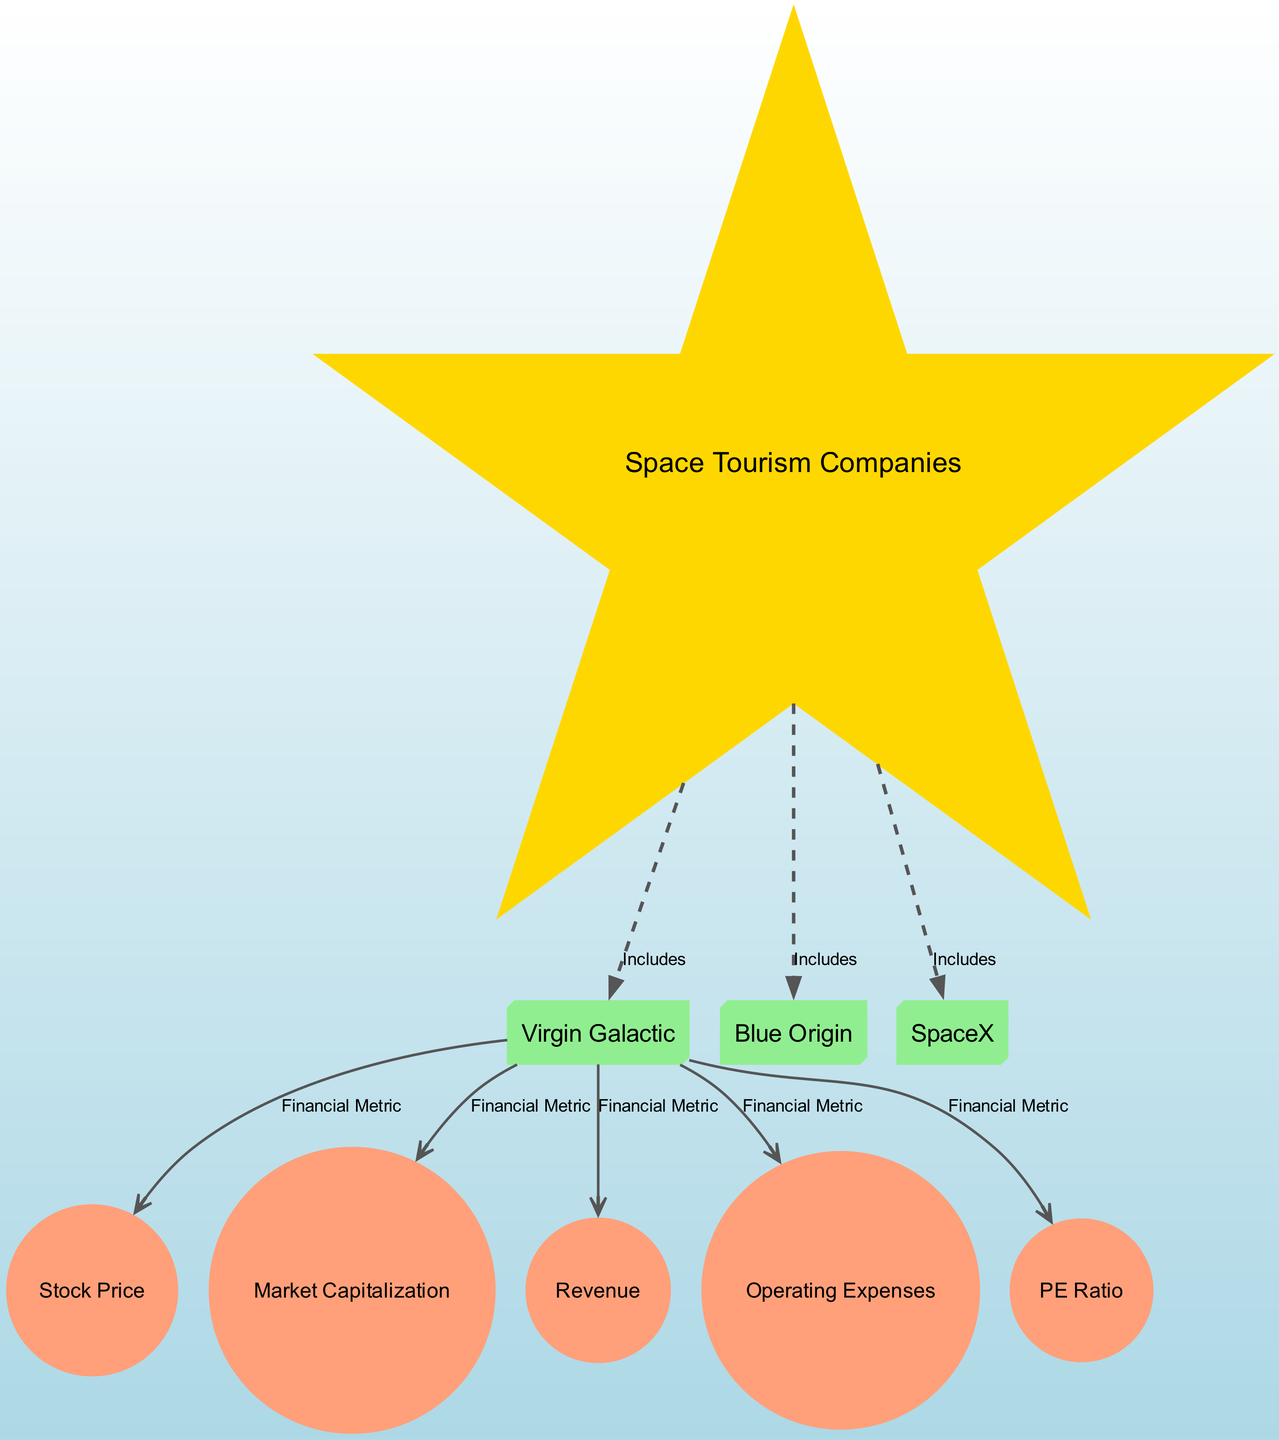What are the space tourism companies included in the diagram? The diagram includes a central node labeled "Space Tourism Companies," which has edges connecting to three nodes: "Virgin Galactic," "Blue Origin," and "SpaceX." This shows that these three companies are included in the space tourism sector.
Answer: Virgin Galactic, Blue Origin, SpaceX How many financial metrics are associated with Virgin Galactic? From the diagram, Virgin Galactic has five edges connecting to different financial metrics: "Stock Price," "Market Capitalization," "Revenue," "Operating Expenses," and "PE Ratio." Therefore, the number of financial metrics associated with Virgin Galactic is five.
Answer: 5 Which company is associated with the highest number of financial metrics? By examining the edges, we see that each of the three space tourism companies (Virgin Galactic, Blue Origin, SpaceX) is connected to the same five financial metrics, indicating they all have an equal number of associations. Thus, no single company is higher than the others in this regard.
Answer: All companies What is the main financial metric connected to Blue Origin? The edges leading from "Blue Origin" indicate the financial metrics it relates to. There are five connections that include various metrics but do not prioritize one over the other in the diagram. Since no single metric is highlighted, we can say that Blue Origin connects to multiple financial metrics equally.
Answer: Multiple metrics What type of relationships are present in the diagram? The diagram contains two types of relationships: "Includes," which is shown as a dashed line, and "Financial Metric," represented by a solid line connecting the companies to the metrics. The inclusion relationship denotes a categorical connection, while the financial metrics emphasize data associations.
Answer: Includes and Financial Metric How is the relationship between SpaceX and its stock price represented? The stock price is linked to SpaceX through a solid edge that classifies it under the financial metric category. It represents a direct connection indicating that SpaceX has a specific stock price value in relation to its financial metrics.
Answer: Solid edge Which financial metric represents the total market value of shares? The financial metric labeled "Market Capitalization" describes the total market value of a company's outstanding shares, indicating its financial standing in the stock market.
Answer: Market Capitalization How many total nodes are present in this diagram? Counting all the nodes, we find one center node, three company nodes, and five financial metric nodes, resulting in a total of nine nodes in the diagram.
Answer: 9 Is the PE Ratio considered a financial metric? Yes, the diagram explicitly lists "PE Ratio" as one of the financial metric nodes connected to each space tourism company, confirming its status as a financial metric.
Answer: Yes 